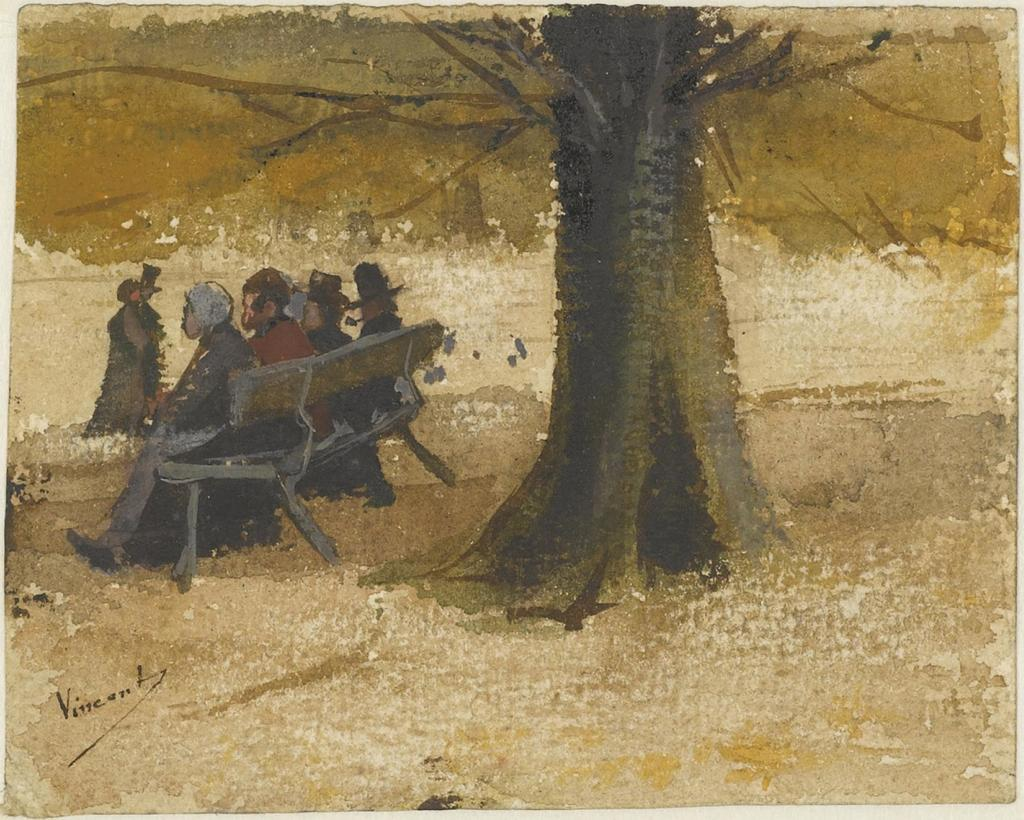What type of artwork is depicted in the image? The image is a painting. What are the people in the painting doing? There are people sitting on a bench in the painting. Are there any other figures in the painting besides those sitting on the bench? Yes, there is a person standing in the painting. What type of natural element is present in the painting? There is a tree in the painting. What direction can be seen on the flag in the painting? There is no flag present in the painting, so it is not possible to determine if a direction is visible on it. 